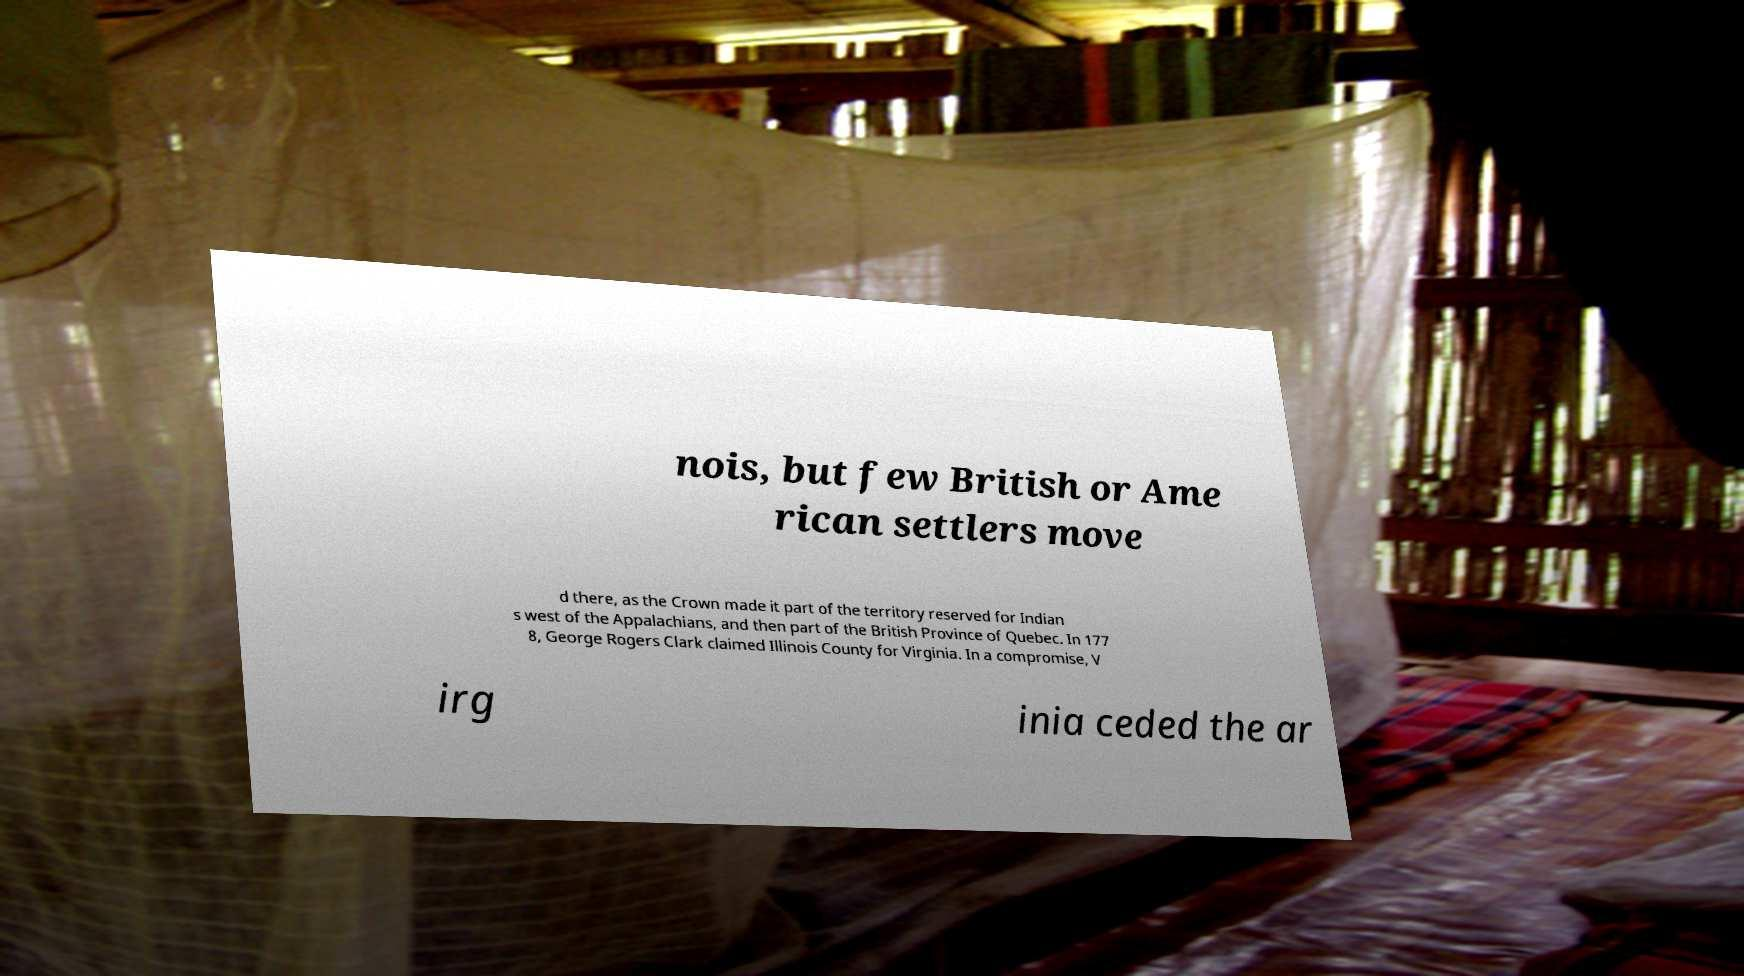There's text embedded in this image that I need extracted. Can you transcribe it verbatim? nois, but few British or Ame rican settlers move d there, as the Crown made it part of the territory reserved for Indian s west of the Appalachians, and then part of the British Province of Quebec. In 177 8, George Rogers Clark claimed Illinois County for Virginia. In a compromise, V irg inia ceded the ar 